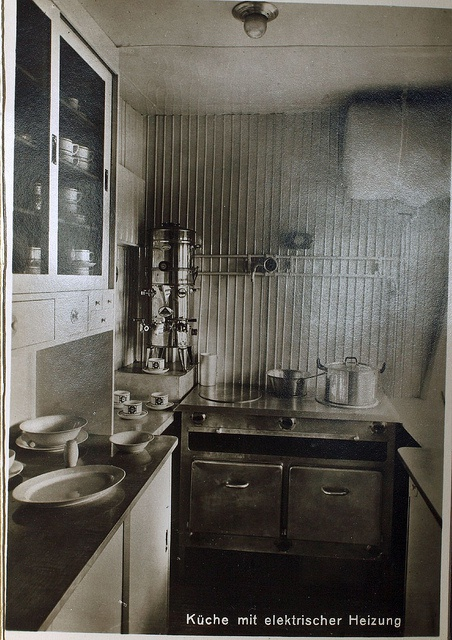Describe the objects in this image and their specific colors. I can see oven in white, black, and gray tones, bowl in white, gray, darkgray, and black tones, bowl in white, gray, darkgray, black, and lightgray tones, bowl in white, darkgray, black, and gray tones, and cup in white, gray, darkgray, and black tones in this image. 